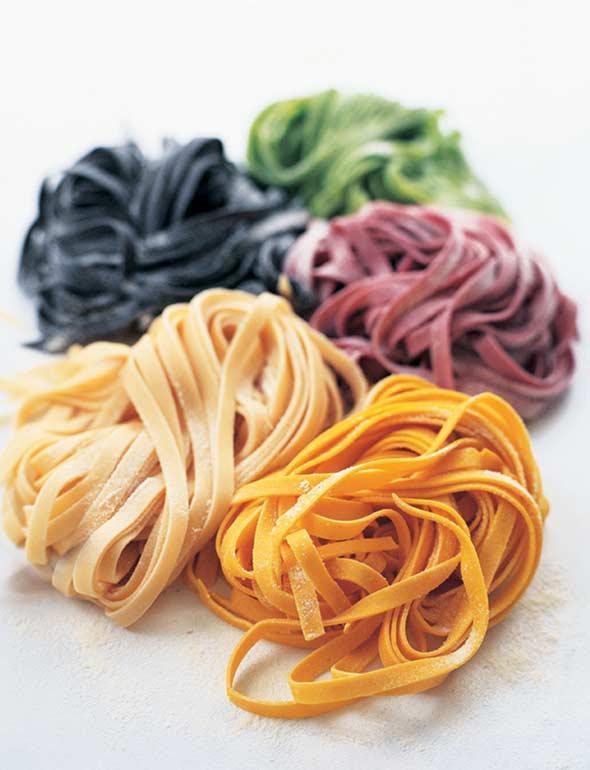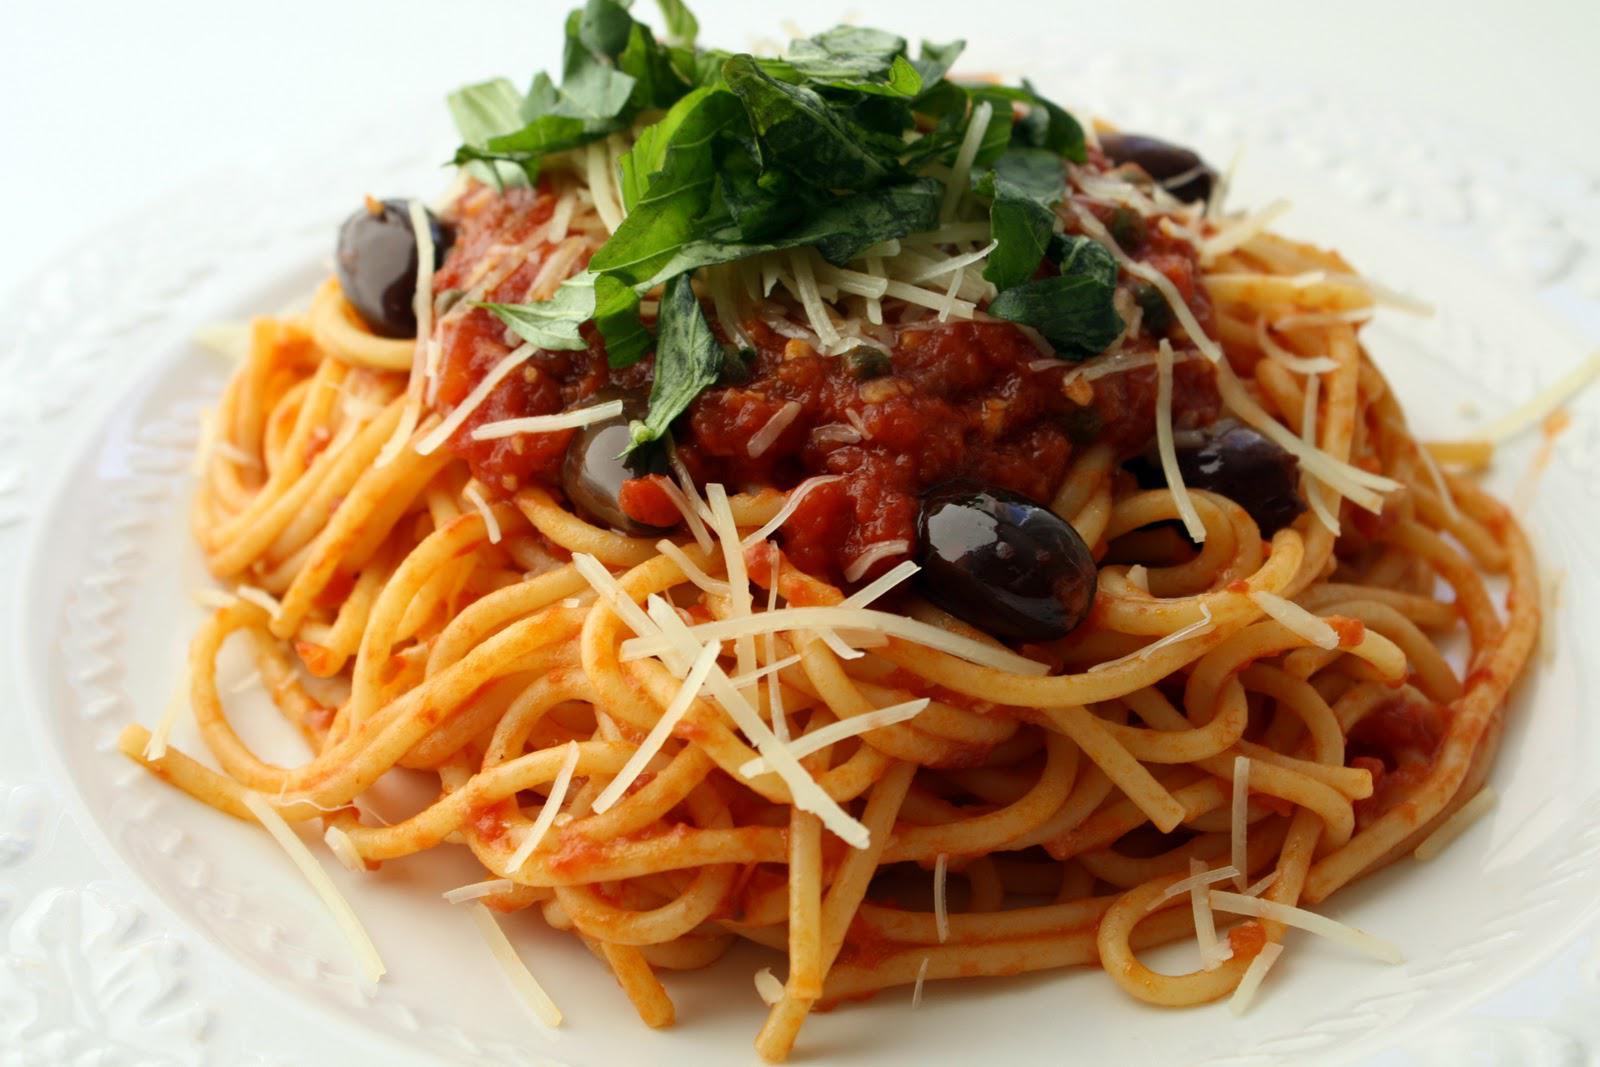The first image is the image on the left, the second image is the image on the right. Considering the images on both sides, is "One image includes a floured board and squarish pastries with mounded middles and scalloped edges, and the other image features noodles in a pile." valid? Answer yes or no. No. The first image is the image on the left, the second image is the image on the right. Examine the images to the left and right. Is the description "A cooking instrument is seen on the table in one of the images." accurate? Answer yes or no. No. 